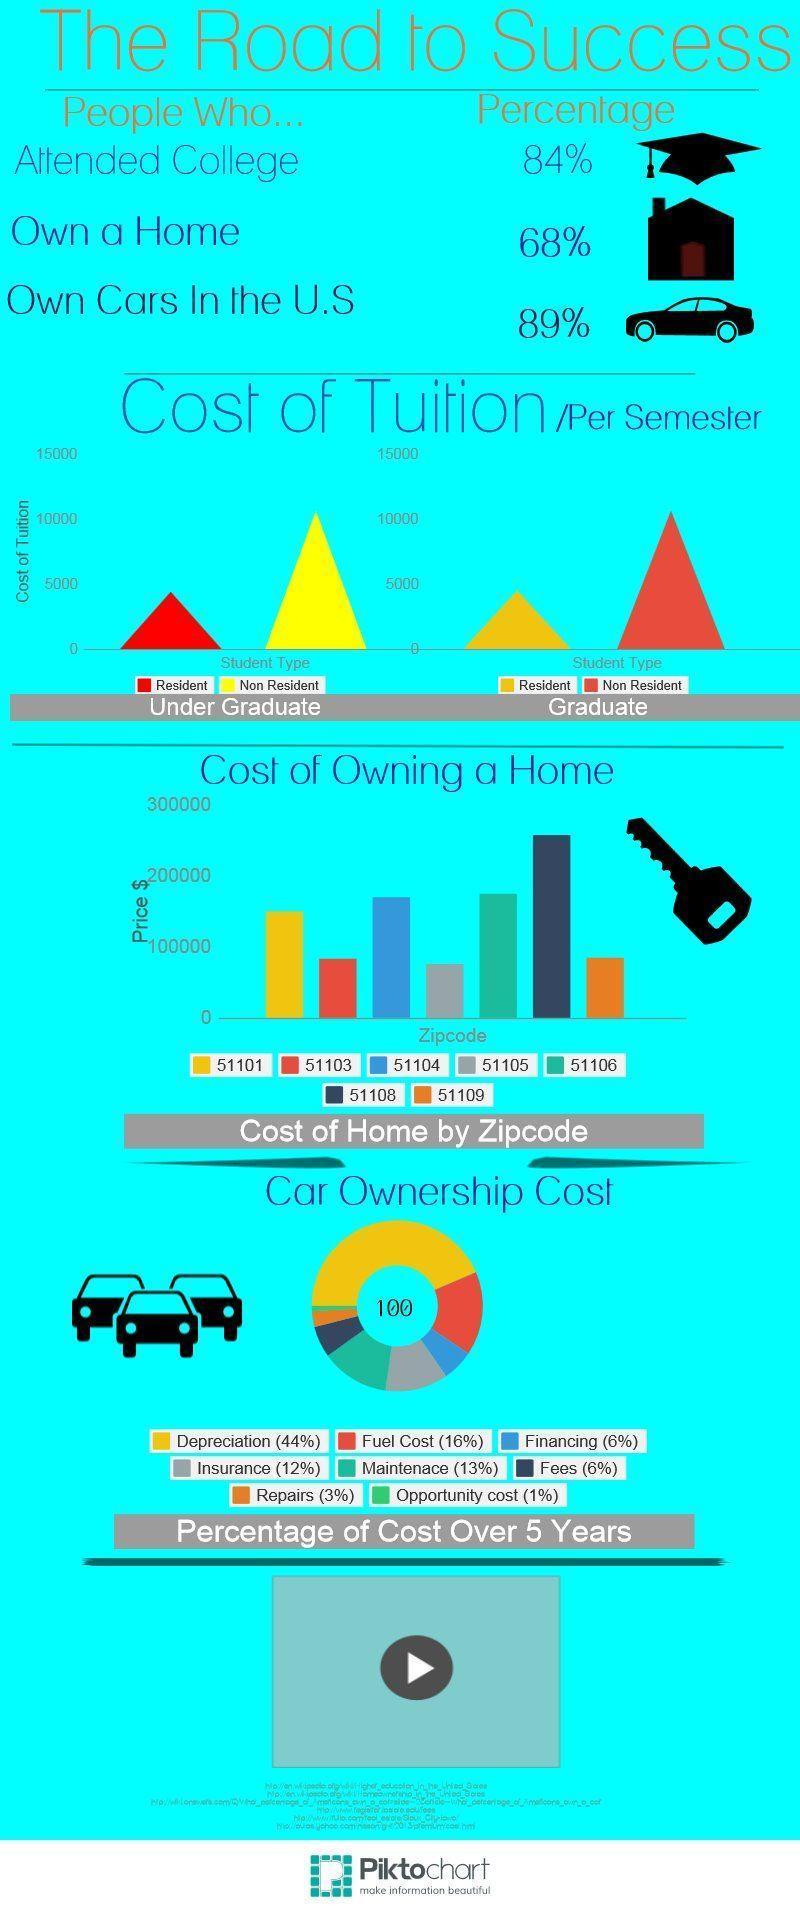What is the percentage of car insurance cost in the U.S.?
Answer the question with a short phrase. (12%) In which zip code area of U.S., the cost of owning a home is above $200000? 51108 In which zip code areas of U.S., the cost of owning a home is in the range of  $100000-$200000? 51101, 51104, 51106 What is the cost of tuition per semester for non resident students who is pursuing a graduate degree in U.S.? 10000 What percentage of people didn't attend colleges in the U.S.? 16% What percentage of people do not own a home in the U.S.? 32% What is the percentage of car maintenance cost in the U.S.? (13%) What is the cost of tuition per semester for non resident students who is pursuing an undergraduate degree in U.S.? 10000 What percentage of people do not own cars in the U.S.? 11% In which zip code areas of U.S., the cost of owning a home is below $100000? 51103, 51105, 51109 